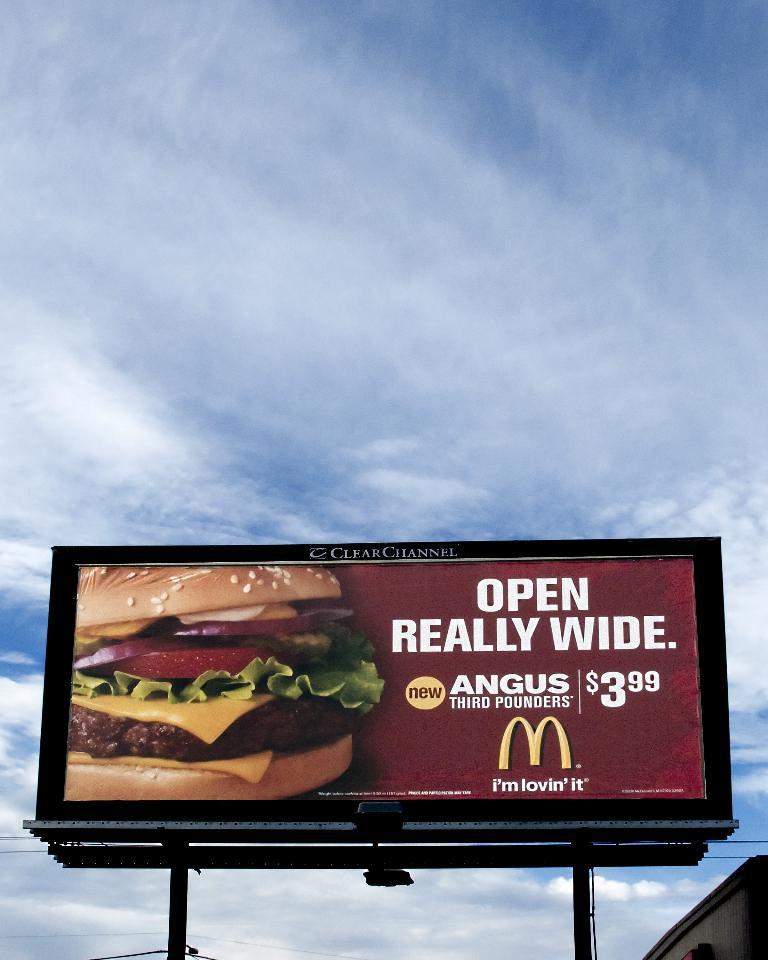How much is the angus third pounder?
Offer a very short reply. 3.99. What restaurant is the billboard advertising for>?
Keep it short and to the point. Mcdonalds. 